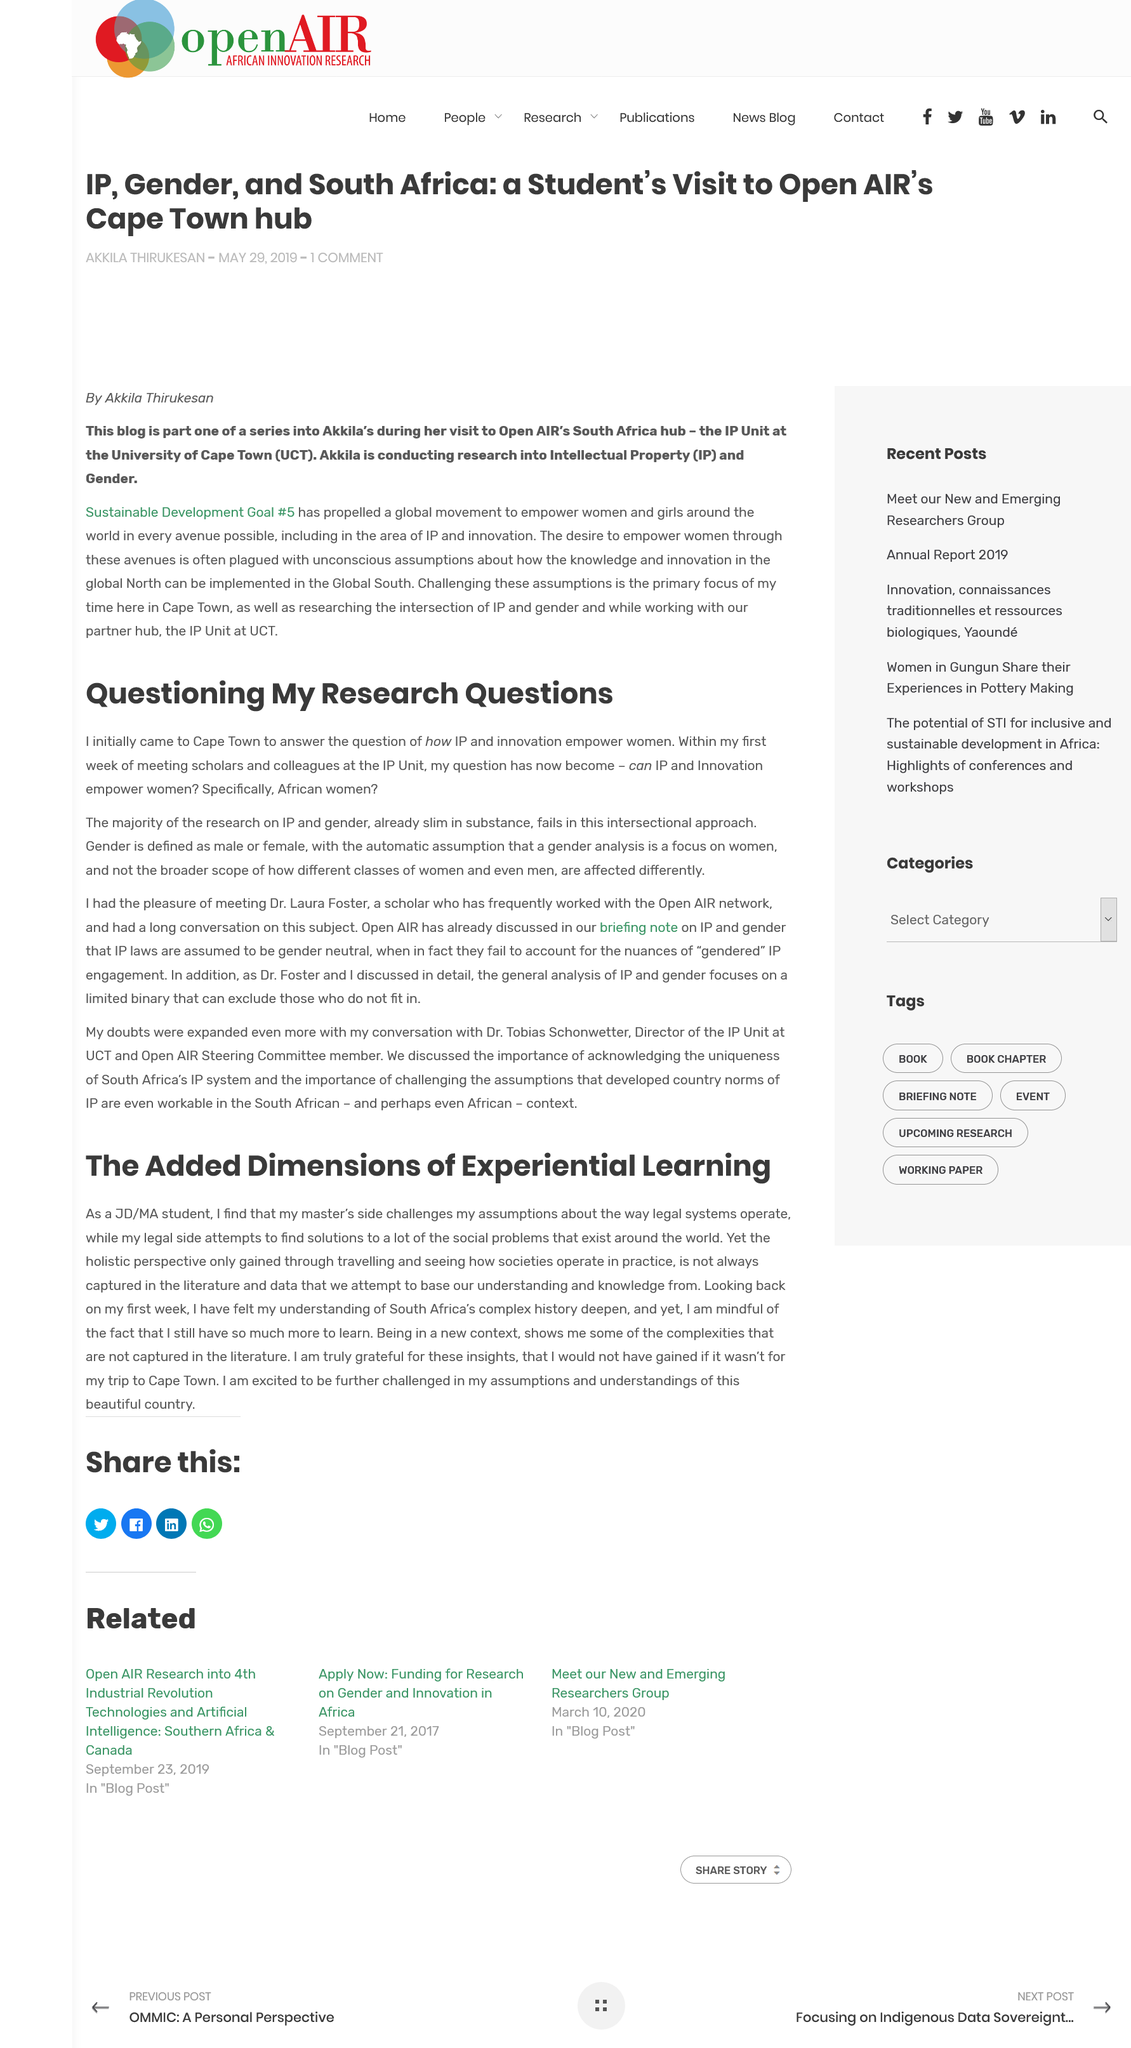List a handful of essential elements in this visual. Being in a new context reveals to the author the intricacies and nuances that are not captured in literature. The author traveled to Cape Town. The author's understanding of South Africa's complex history became more profound as they delved deeper into their research. 